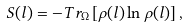Convert formula to latex. <formula><loc_0><loc_0><loc_500><loc_500>S ( l ) = - T r _ { \Omega } \left [ \rho ( l ) \ln \rho ( l ) \right ] ,</formula> 